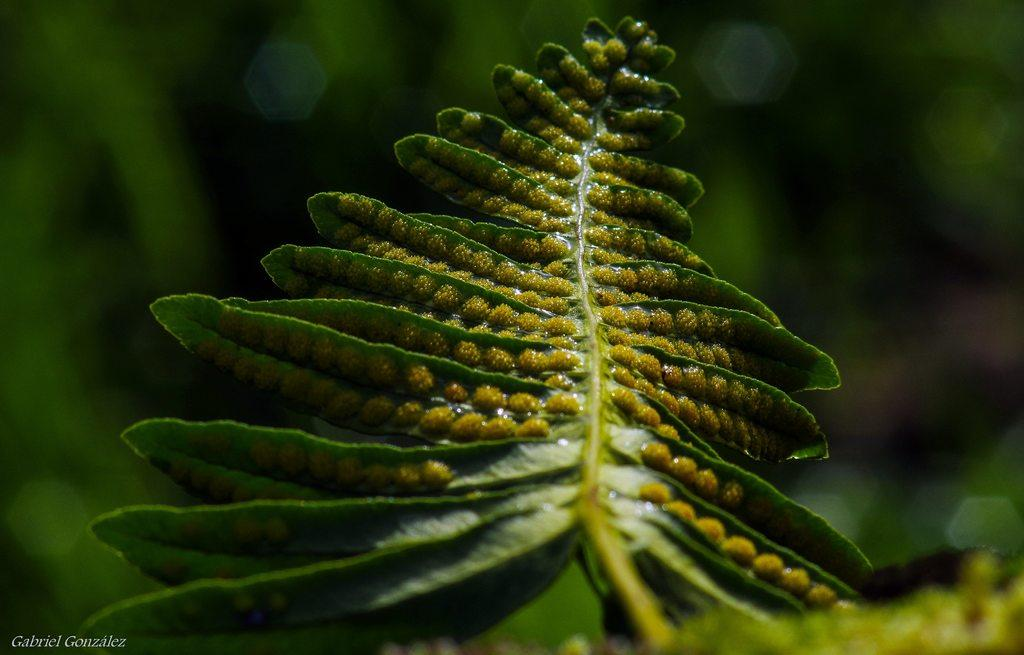What type of vegetation can be seen in the image? There are leaves in the image. Can you describe the background of the image? The background of the image is blurred. How does the fly express regret on the plate in the image? There is no fly or plate present in the image, so this situation cannot be observed. 